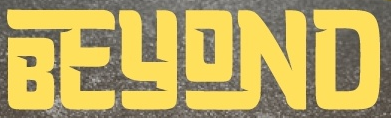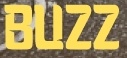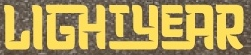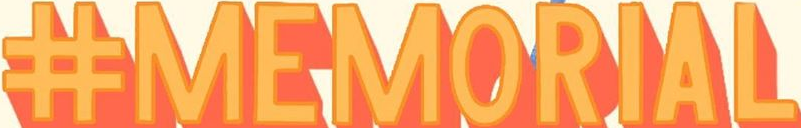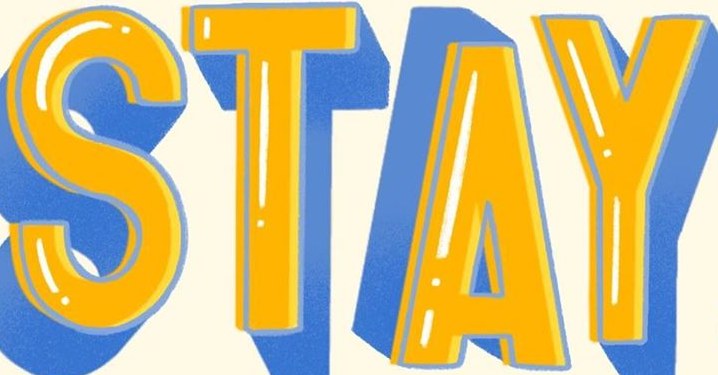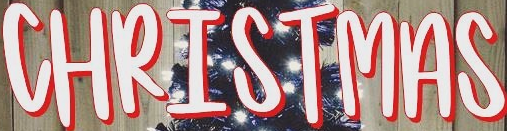What words can you see in these images in sequence, separated by a semicolon? BEYOND; BUZZ; LIGHTYEAR; #MEMORIAL; STAY; CHRISTMAS 